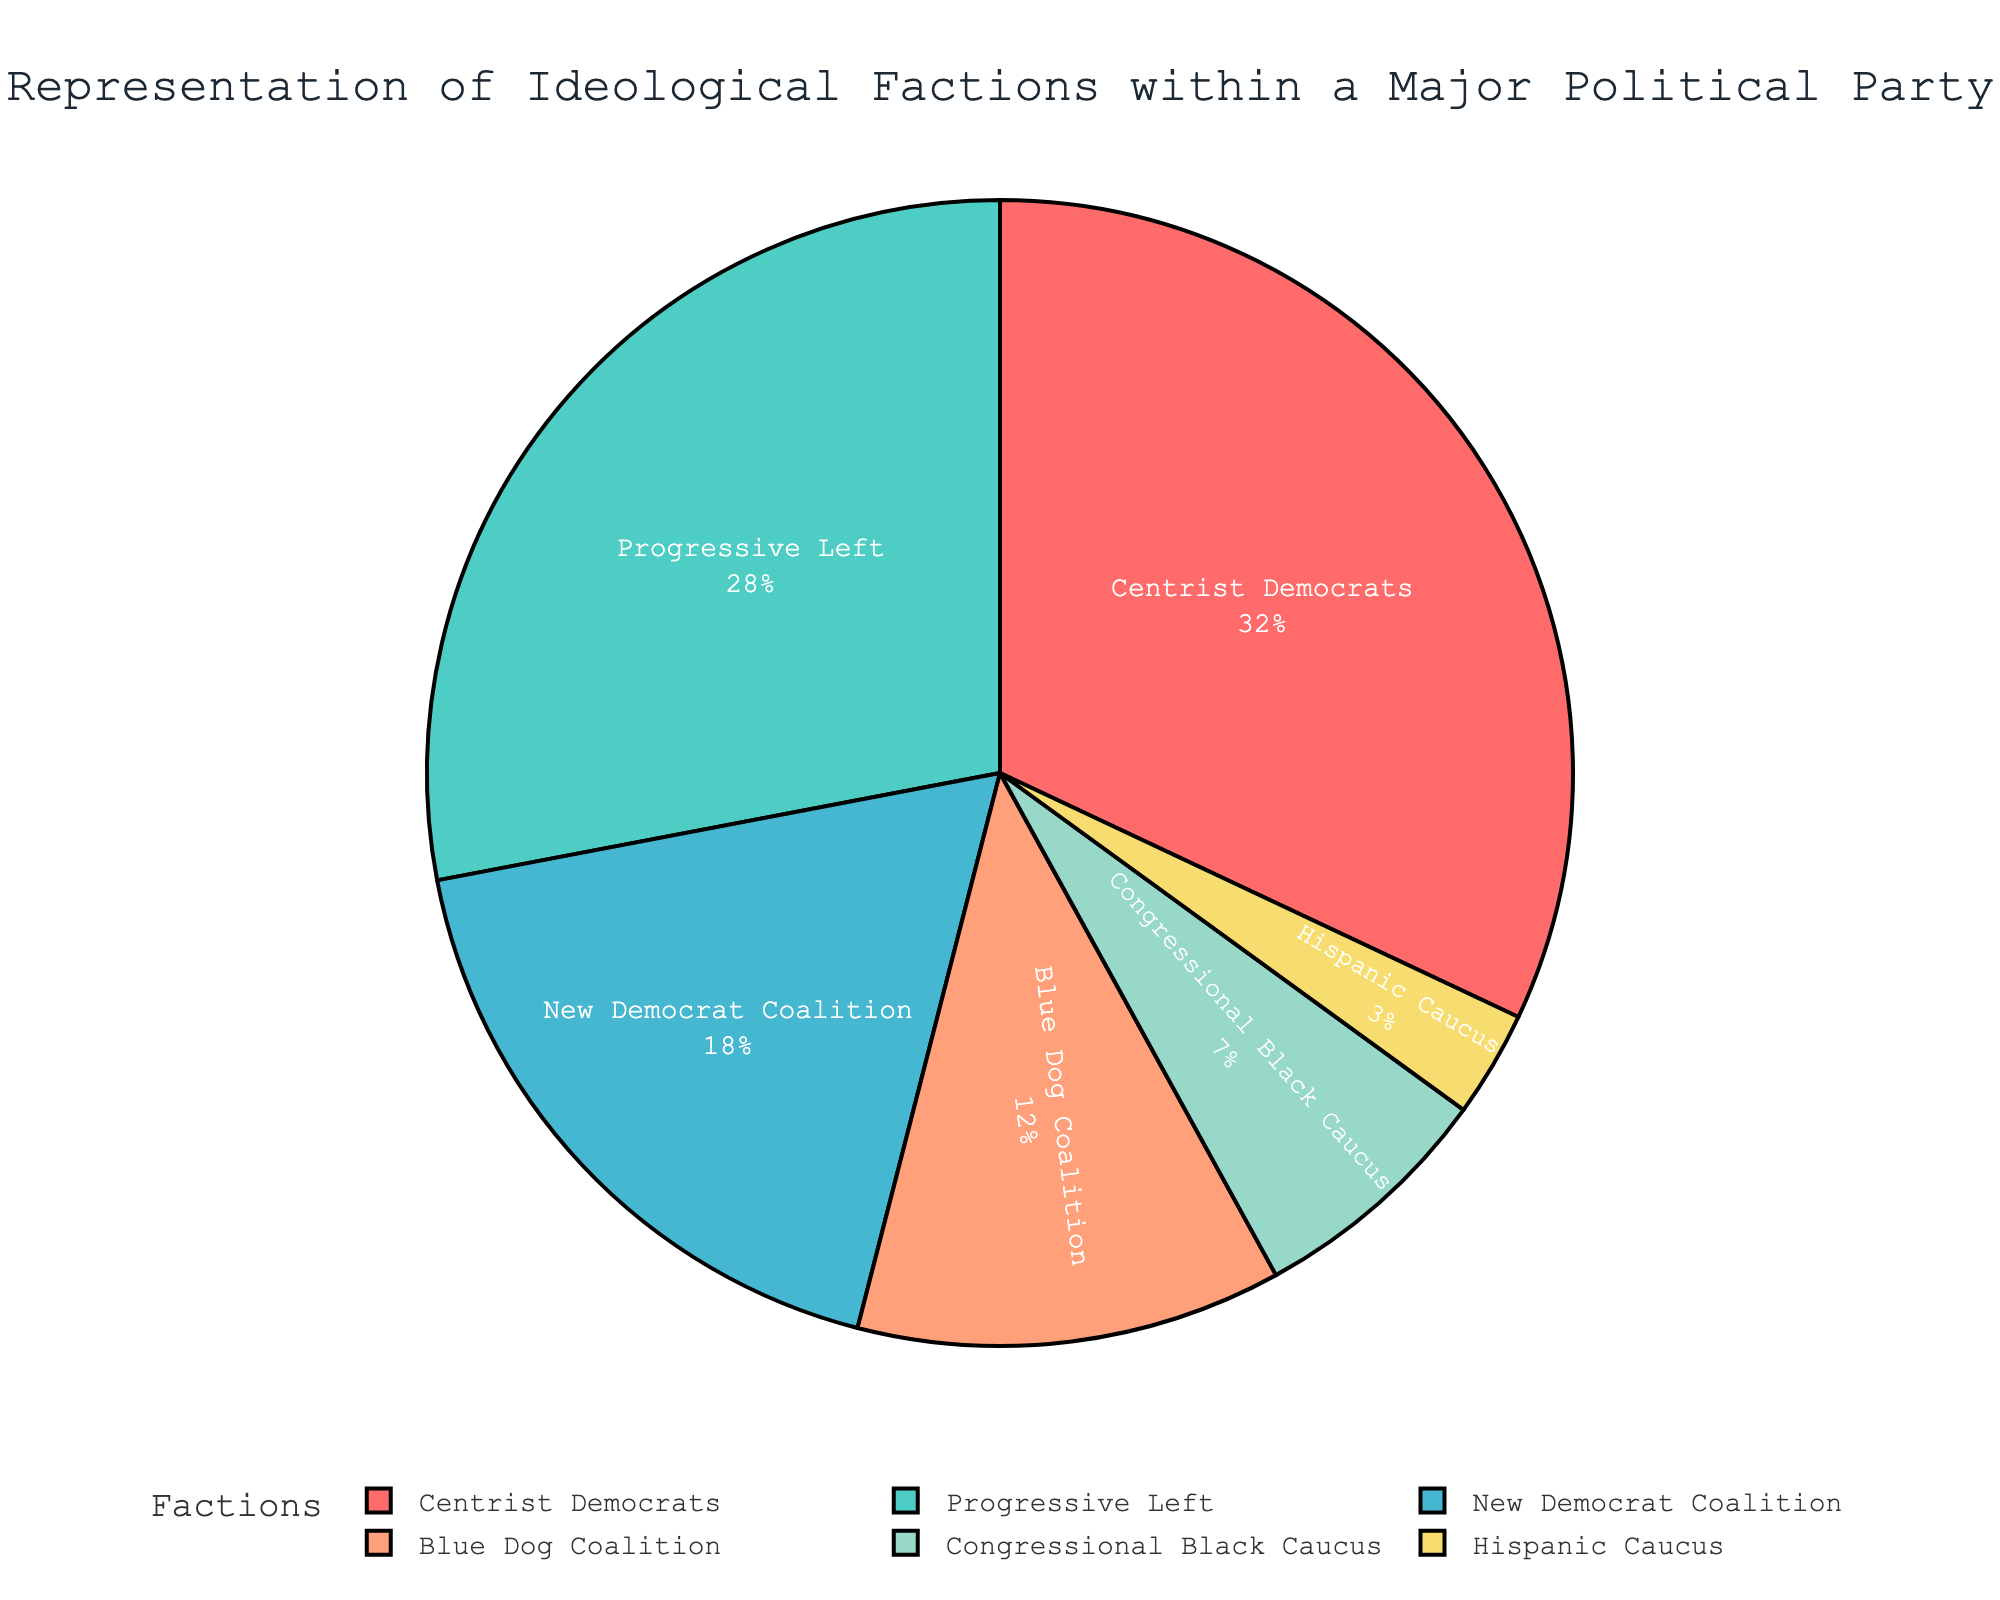What percentage of the factions fall under the category of minority representation (Congressional Black Caucus and Hispanic Caucus)? Add the percentages of Congressional Black Caucus and Hispanic Caucus: 7% + 3% = 10%
Answer: 10% Which faction has the largest representation within the party? The largest slice of the pie chart corresponds to Centrist Democrats with 32%
Answer: Centrist Democrats How much larger is the Progressive Left faction compared to the Blue Dog Coalition? Subtract the percentage of the Blue Dog Coalition from the Progressive Left: 28% - 12% = 16%
Answer: 16% Which factions combined make up exactly 50% of the representation? Centrist Democrats (32%) and New Democrat Coalition (18%) combined make 32% + 18% = 50% of the representation
Answer: Centrist Democrats and New Democrat Coalition How does the representation of the Hispanic Caucus compare visually with that of the Progressive Left? The pie slice for the Progressive Left is much larger than that of the Hispanic Caucus. Specifically, Progressive Left is 28%, while Hispanic Caucus is just 3%
Answer: Progressive Left is much larger If you combine the representation of Centrist Democrats and Blue Dog Coalition, is it greater or less than that of the Progressive Left and New Democrat Coalition combined? Sum the percentages: Centrist Democrats (32%) + Blue Dog Coalition (12%) = 44%, Progressive Left (28%) + New Democrat Coalition (18%) = 46%. Therefore, 44% < 46%
Answer: Less What color represents the New Democrat Coalition on the pie chart? The color for each faction is described in the color palette provided. The New Democrat Coalition slice is shaded in a peach color
Answer: Peach Which two factions together equal the representation of the Progressive Left? The factions with representations adding up to 28% are Blue Dog Coalition (12%) and New Democrat Coalition (18%): 12% + 18% = 30%. Note there are no two factions that sum exactly to 28%, but these two are close
Answer: Blue Dog Coalition and New Democrat Coalition (close match) What is the visual difference in size between the Centrist Democrats and the Congressional Black Caucus? Visually, the slice for Centrist Democrats is markedly larger than the smaller slice for the Congressional Black Caucus. Specifically, Centrist Democrats are 32% while Congressional Black Caucus is 7%
Answer: Centrist Democrats is larger If the Progressive Left and New Democrat Coalition were merged into one group, what would be their combined representation? Add the percentages of the Progressive Left and New Democrat Coalition to get the combined representation: 28% + 18% = 46%
Answer: 46% 